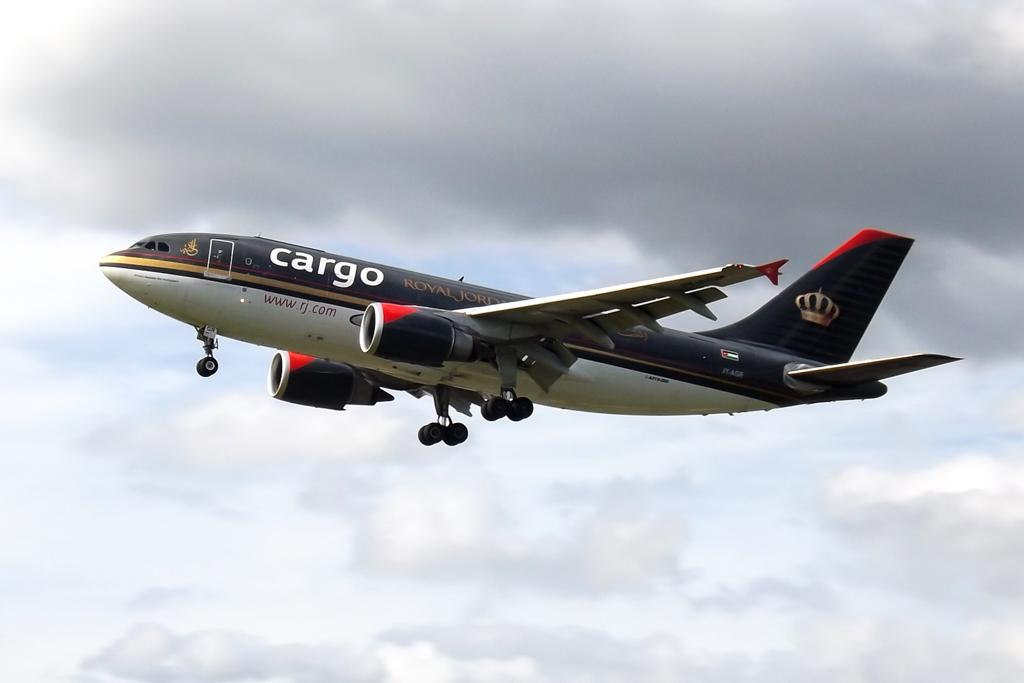What is the main subject of the image? The main subject of the image is an airplane. Can you describe the position of the airplane in the image? The airplane is in the air. What is the condition of the sky in the image? The sky is cloudy in the image. How many family members are seated on the seat in the image? There is no seat or family members present in the image. What year is depicted in the image? The image does not depict a specific year; it only shows an airplane in the air with a cloudy sky. 